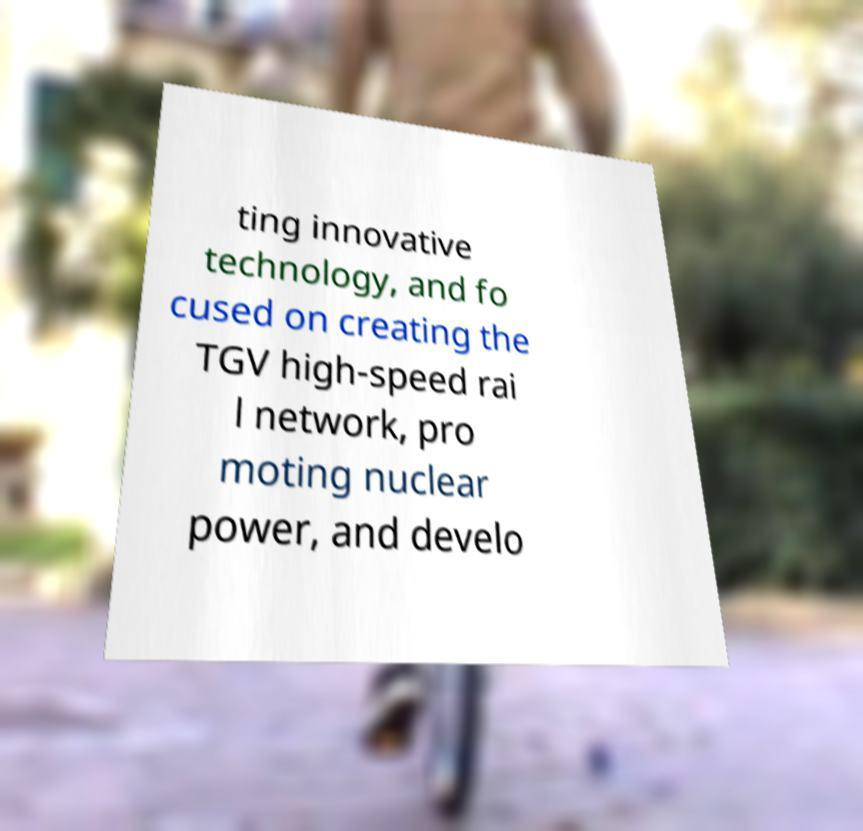Can you accurately transcribe the text from the provided image for me? ting innovative technology, and fo cused on creating the TGV high-speed rai l network, pro moting nuclear power, and develo 